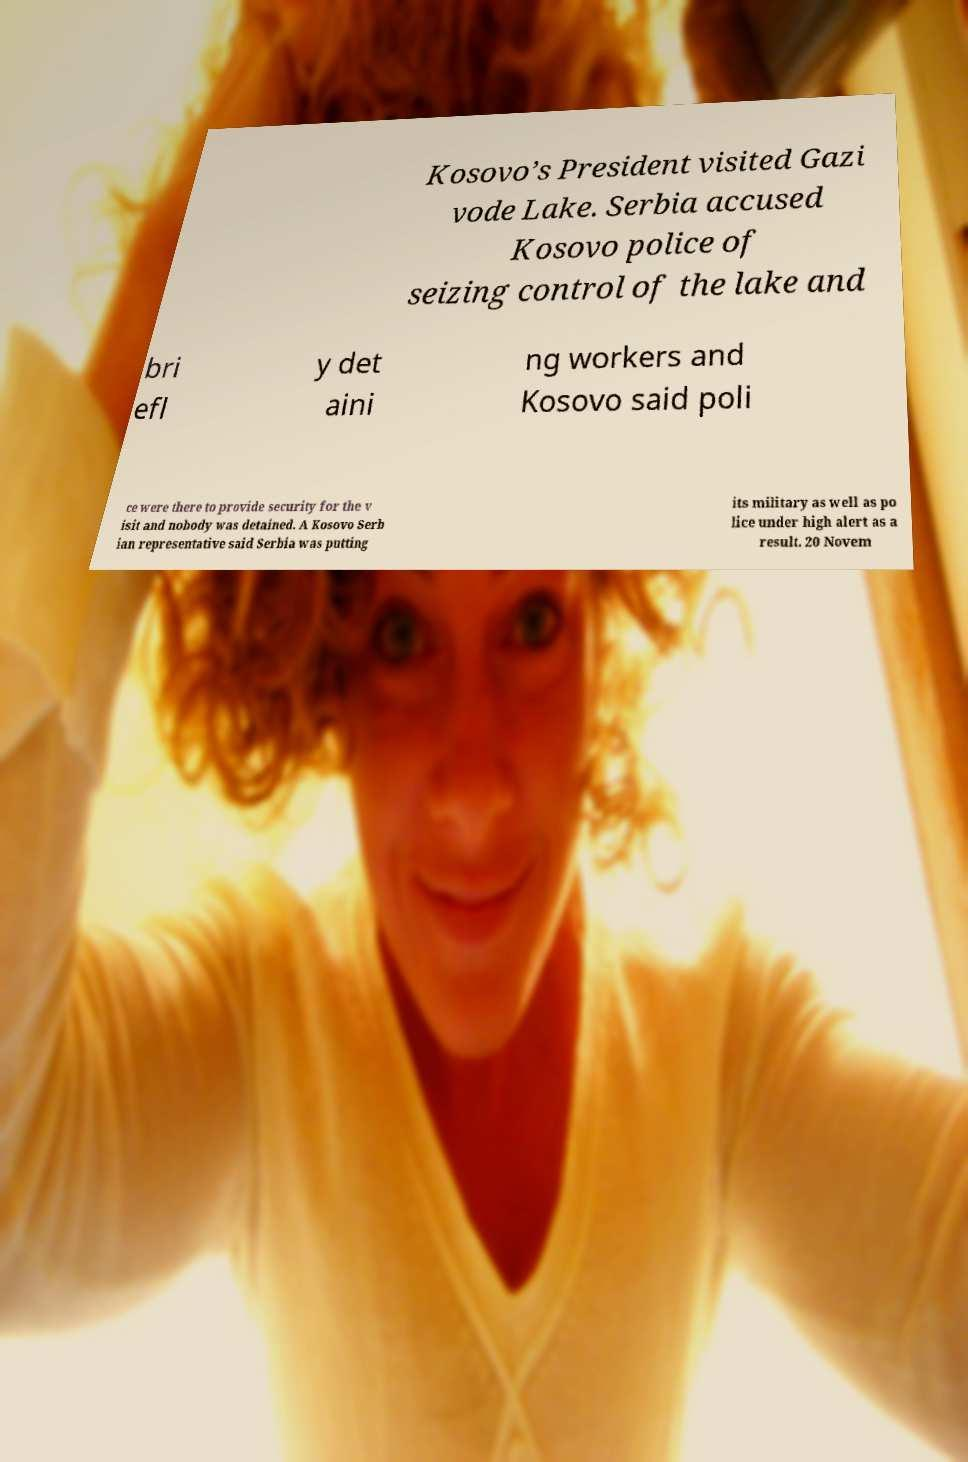Could you extract and type out the text from this image? Kosovo’s President visited Gazi vode Lake. Serbia accused Kosovo police of seizing control of the lake and bri efl y det aini ng workers and Kosovo said poli ce were there to provide security for the v isit and nobody was detained. A Kosovo Serb ian representative said Serbia was putting its military as well as po lice under high alert as a result. 20 Novem 